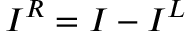Convert formula to latex. <formula><loc_0><loc_0><loc_500><loc_500>I ^ { R } = I - I ^ { L }</formula> 